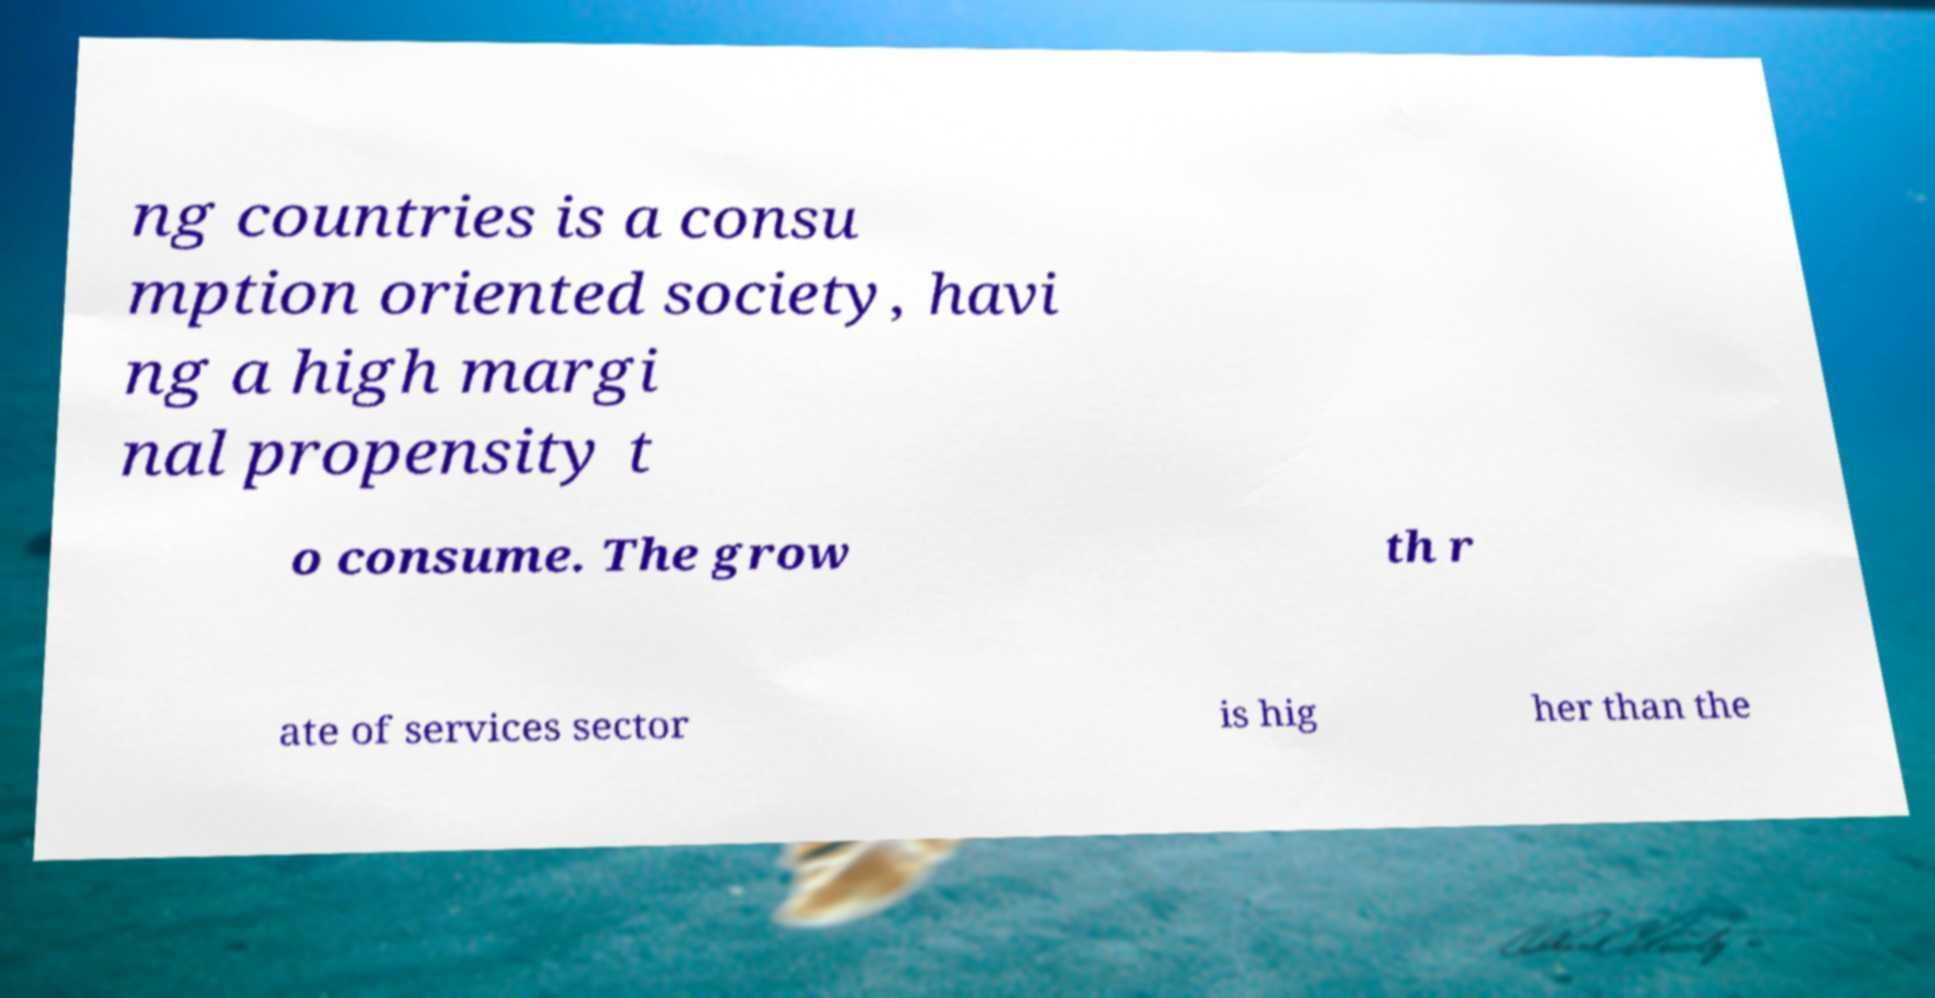Can you accurately transcribe the text from the provided image for me? ng countries is a consu mption oriented society, havi ng a high margi nal propensity t o consume. The grow th r ate of services sector is hig her than the 